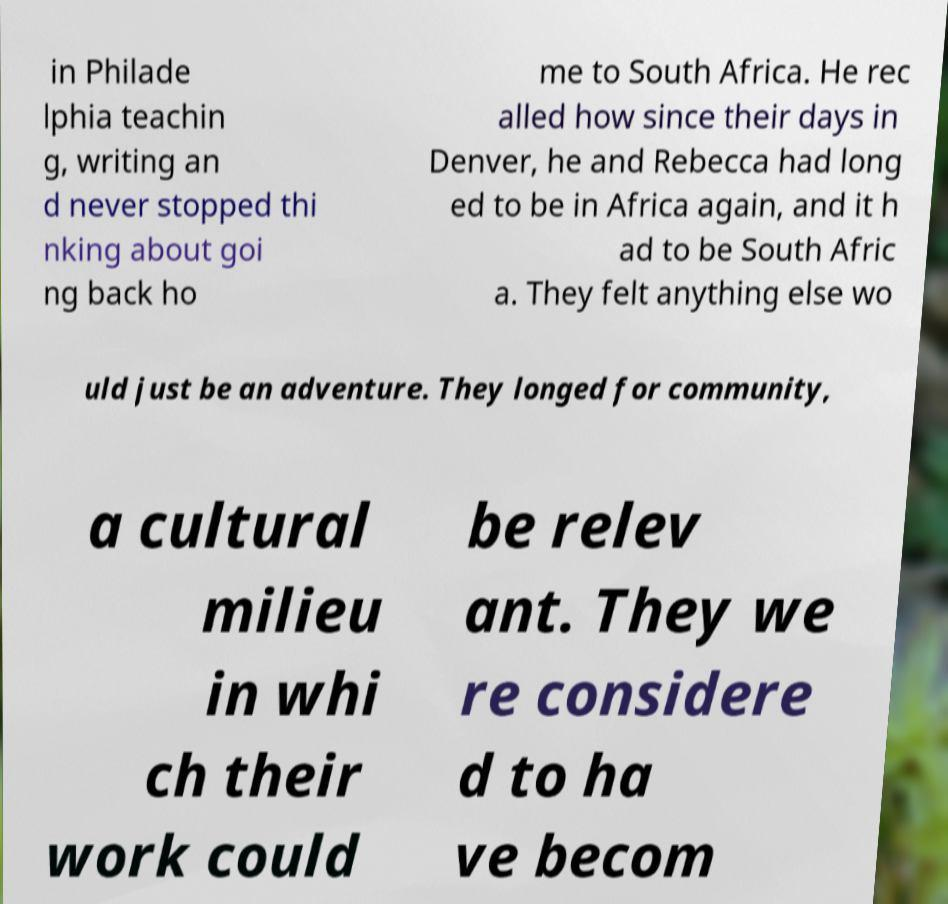Could you assist in decoding the text presented in this image and type it out clearly? in Philade lphia teachin g, writing an d never stopped thi nking about goi ng back ho me to South Africa. He rec alled how since their days in Denver, he and Rebecca had long ed to be in Africa again, and it h ad to be South Afric a. They felt anything else wo uld just be an adventure. They longed for community, a cultural milieu in whi ch their work could be relev ant. They we re considere d to ha ve becom 